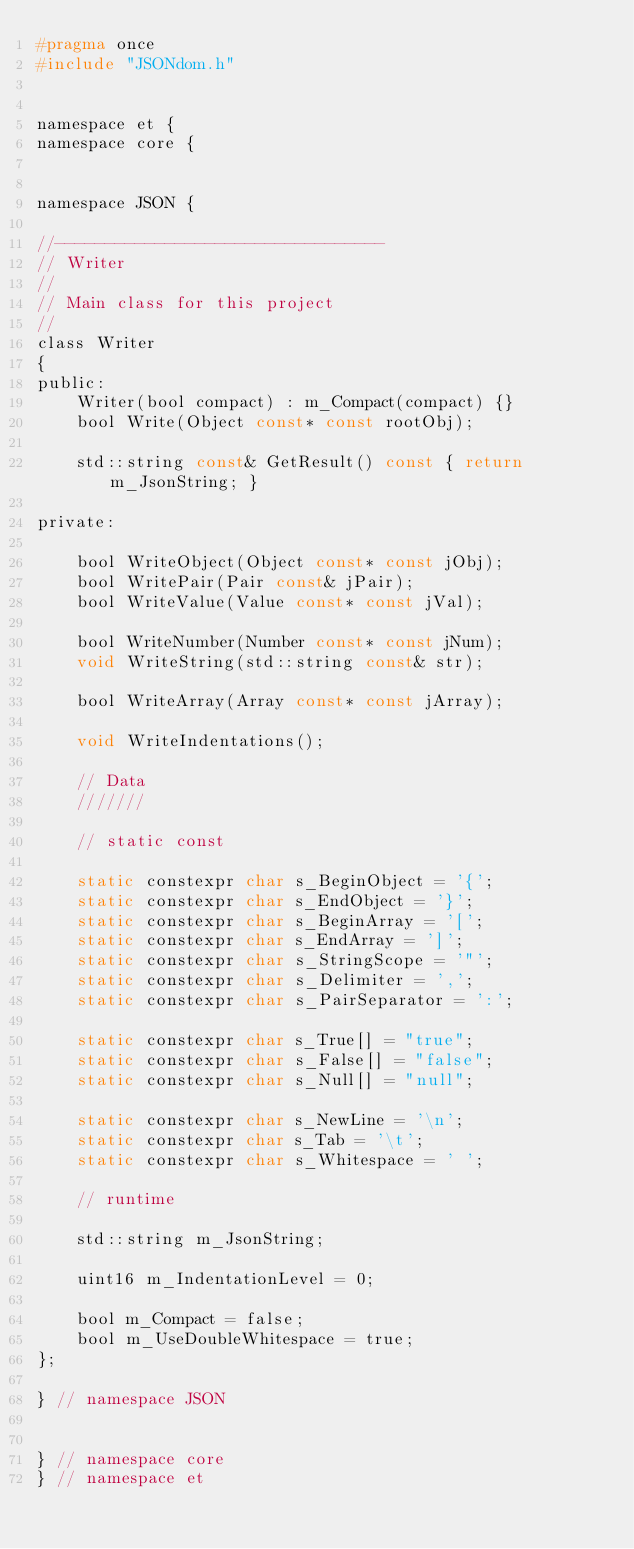<code> <loc_0><loc_0><loc_500><loc_500><_C_>#pragma once
#include "JSONdom.h"


namespace et {
namespace core {


namespace JSON {
	
//---------------------------------
// Writer
//
// Main class for this project
//
class Writer
{
public:
	Writer(bool compact) : m_Compact(compact) {}
	bool Write(Object const* const rootObj);

	std::string const& GetResult() const { return m_JsonString; }

private:

	bool WriteObject(Object const* const jObj);
	bool WritePair(Pair const& jPair);
	bool WriteValue(Value const* const jVal);

	bool WriteNumber(Number const* const jNum);
	void WriteString(std::string const& str);

	bool WriteArray(Array const* const jArray);

	void WriteIndentations();

	// Data
	///////

	// static const

	static constexpr char s_BeginObject = '{';
	static constexpr char s_EndObject = '}';
	static constexpr char s_BeginArray = '[';
	static constexpr char s_EndArray = ']';
	static constexpr char s_StringScope = '"';
	static constexpr char s_Delimiter = ',';
	static constexpr char s_PairSeparator = ':';

	static constexpr char s_True[] = "true";
	static constexpr char s_False[] = "false";
	static constexpr char s_Null[] = "null";

	static constexpr char s_NewLine = '\n';
	static constexpr char s_Tab = '\t';
	static constexpr char s_Whitespace = ' ';

	// runtime

	std::string m_JsonString;

	uint16 m_IndentationLevel = 0;

	bool m_Compact = false;
	bool m_UseDoubleWhitespace = true;
};

} // namespace JSON


} // namespace core
} // namespace et
</code> 